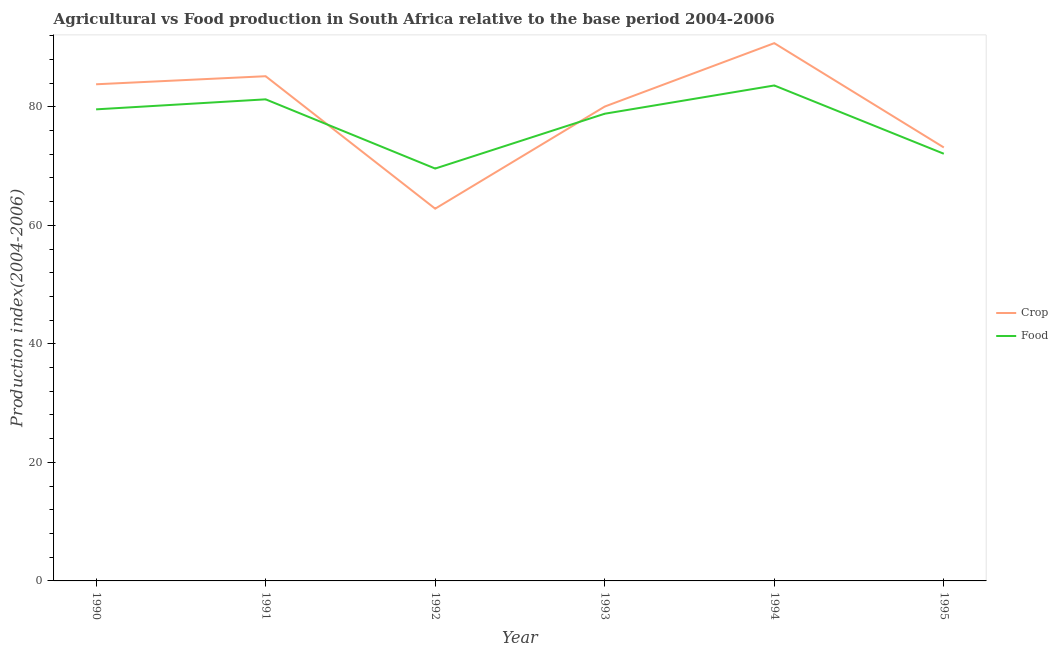What is the food production index in 1992?
Give a very brief answer. 69.58. Across all years, what is the maximum crop production index?
Your response must be concise. 90.74. Across all years, what is the minimum crop production index?
Offer a terse response. 62.81. What is the total food production index in the graph?
Your answer should be compact. 464.92. What is the difference between the food production index in 1993 and that in 1995?
Provide a short and direct response. 6.75. What is the difference between the food production index in 1995 and the crop production index in 1992?
Your answer should be very brief. 9.27. What is the average food production index per year?
Give a very brief answer. 77.49. In the year 1994, what is the difference between the crop production index and food production index?
Your answer should be compact. 7.14. What is the ratio of the food production index in 1990 to that in 1995?
Your response must be concise. 1.1. What is the difference between the highest and the second highest food production index?
Keep it short and to the point. 2.34. What is the difference between the highest and the lowest crop production index?
Your answer should be very brief. 27.93. Does the crop production index monotonically increase over the years?
Your answer should be compact. No. Are the values on the major ticks of Y-axis written in scientific E-notation?
Your answer should be compact. No. Does the graph contain grids?
Your answer should be very brief. No. How many legend labels are there?
Give a very brief answer. 2. What is the title of the graph?
Offer a very short reply. Agricultural vs Food production in South Africa relative to the base period 2004-2006. What is the label or title of the Y-axis?
Ensure brevity in your answer.  Production index(2004-2006). What is the Production index(2004-2006) of Crop in 1990?
Your response must be concise. 83.8. What is the Production index(2004-2006) of Food in 1990?
Your answer should be compact. 79.57. What is the Production index(2004-2006) in Crop in 1991?
Offer a terse response. 85.16. What is the Production index(2004-2006) of Food in 1991?
Offer a terse response. 81.26. What is the Production index(2004-2006) in Crop in 1992?
Your answer should be very brief. 62.81. What is the Production index(2004-2006) of Food in 1992?
Make the answer very short. 69.58. What is the Production index(2004-2006) of Crop in 1993?
Provide a succinct answer. 80.04. What is the Production index(2004-2006) of Food in 1993?
Give a very brief answer. 78.83. What is the Production index(2004-2006) in Crop in 1994?
Make the answer very short. 90.74. What is the Production index(2004-2006) in Food in 1994?
Your answer should be compact. 83.6. What is the Production index(2004-2006) of Crop in 1995?
Your response must be concise. 73.14. What is the Production index(2004-2006) of Food in 1995?
Your answer should be compact. 72.08. Across all years, what is the maximum Production index(2004-2006) in Crop?
Your response must be concise. 90.74. Across all years, what is the maximum Production index(2004-2006) in Food?
Provide a short and direct response. 83.6. Across all years, what is the minimum Production index(2004-2006) in Crop?
Offer a very short reply. 62.81. Across all years, what is the minimum Production index(2004-2006) of Food?
Your answer should be very brief. 69.58. What is the total Production index(2004-2006) in Crop in the graph?
Offer a very short reply. 475.69. What is the total Production index(2004-2006) of Food in the graph?
Your answer should be very brief. 464.92. What is the difference between the Production index(2004-2006) in Crop in 1990 and that in 1991?
Your response must be concise. -1.36. What is the difference between the Production index(2004-2006) in Food in 1990 and that in 1991?
Your answer should be very brief. -1.69. What is the difference between the Production index(2004-2006) of Crop in 1990 and that in 1992?
Offer a terse response. 20.99. What is the difference between the Production index(2004-2006) of Food in 1990 and that in 1992?
Your answer should be compact. 9.99. What is the difference between the Production index(2004-2006) in Crop in 1990 and that in 1993?
Provide a succinct answer. 3.76. What is the difference between the Production index(2004-2006) in Food in 1990 and that in 1993?
Ensure brevity in your answer.  0.74. What is the difference between the Production index(2004-2006) in Crop in 1990 and that in 1994?
Offer a very short reply. -6.94. What is the difference between the Production index(2004-2006) in Food in 1990 and that in 1994?
Offer a very short reply. -4.03. What is the difference between the Production index(2004-2006) in Crop in 1990 and that in 1995?
Your answer should be very brief. 10.66. What is the difference between the Production index(2004-2006) of Food in 1990 and that in 1995?
Give a very brief answer. 7.49. What is the difference between the Production index(2004-2006) in Crop in 1991 and that in 1992?
Provide a short and direct response. 22.35. What is the difference between the Production index(2004-2006) of Food in 1991 and that in 1992?
Keep it short and to the point. 11.68. What is the difference between the Production index(2004-2006) of Crop in 1991 and that in 1993?
Your answer should be very brief. 5.12. What is the difference between the Production index(2004-2006) of Food in 1991 and that in 1993?
Your response must be concise. 2.43. What is the difference between the Production index(2004-2006) in Crop in 1991 and that in 1994?
Provide a succinct answer. -5.58. What is the difference between the Production index(2004-2006) of Food in 1991 and that in 1994?
Keep it short and to the point. -2.34. What is the difference between the Production index(2004-2006) of Crop in 1991 and that in 1995?
Keep it short and to the point. 12.02. What is the difference between the Production index(2004-2006) in Food in 1991 and that in 1995?
Your answer should be compact. 9.18. What is the difference between the Production index(2004-2006) in Crop in 1992 and that in 1993?
Offer a very short reply. -17.23. What is the difference between the Production index(2004-2006) of Food in 1992 and that in 1993?
Ensure brevity in your answer.  -9.25. What is the difference between the Production index(2004-2006) of Crop in 1992 and that in 1994?
Make the answer very short. -27.93. What is the difference between the Production index(2004-2006) of Food in 1992 and that in 1994?
Offer a terse response. -14.02. What is the difference between the Production index(2004-2006) of Crop in 1992 and that in 1995?
Make the answer very short. -10.33. What is the difference between the Production index(2004-2006) in Food in 1993 and that in 1994?
Keep it short and to the point. -4.77. What is the difference between the Production index(2004-2006) of Food in 1993 and that in 1995?
Ensure brevity in your answer.  6.75. What is the difference between the Production index(2004-2006) in Food in 1994 and that in 1995?
Make the answer very short. 11.52. What is the difference between the Production index(2004-2006) of Crop in 1990 and the Production index(2004-2006) of Food in 1991?
Your response must be concise. 2.54. What is the difference between the Production index(2004-2006) of Crop in 1990 and the Production index(2004-2006) of Food in 1992?
Ensure brevity in your answer.  14.22. What is the difference between the Production index(2004-2006) of Crop in 1990 and the Production index(2004-2006) of Food in 1993?
Your response must be concise. 4.97. What is the difference between the Production index(2004-2006) in Crop in 1990 and the Production index(2004-2006) in Food in 1994?
Your answer should be very brief. 0.2. What is the difference between the Production index(2004-2006) in Crop in 1990 and the Production index(2004-2006) in Food in 1995?
Offer a very short reply. 11.72. What is the difference between the Production index(2004-2006) in Crop in 1991 and the Production index(2004-2006) in Food in 1992?
Offer a terse response. 15.58. What is the difference between the Production index(2004-2006) in Crop in 1991 and the Production index(2004-2006) in Food in 1993?
Your response must be concise. 6.33. What is the difference between the Production index(2004-2006) in Crop in 1991 and the Production index(2004-2006) in Food in 1994?
Make the answer very short. 1.56. What is the difference between the Production index(2004-2006) of Crop in 1991 and the Production index(2004-2006) of Food in 1995?
Make the answer very short. 13.08. What is the difference between the Production index(2004-2006) of Crop in 1992 and the Production index(2004-2006) of Food in 1993?
Keep it short and to the point. -16.02. What is the difference between the Production index(2004-2006) in Crop in 1992 and the Production index(2004-2006) in Food in 1994?
Give a very brief answer. -20.79. What is the difference between the Production index(2004-2006) of Crop in 1992 and the Production index(2004-2006) of Food in 1995?
Make the answer very short. -9.27. What is the difference between the Production index(2004-2006) in Crop in 1993 and the Production index(2004-2006) in Food in 1994?
Keep it short and to the point. -3.56. What is the difference between the Production index(2004-2006) in Crop in 1993 and the Production index(2004-2006) in Food in 1995?
Offer a terse response. 7.96. What is the difference between the Production index(2004-2006) in Crop in 1994 and the Production index(2004-2006) in Food in 1995?
Provide a short and direct response. 18.66. What is the average Production index(2004-2006) in Crop per year?
Provide a succinct answer. 79.28. What is the average Production index(2004-2006) in Food per year?
Provide a short and direct response. 77.49. In the year 1990, what is the difference between the Production index(2004-2006) in Crop and Production index(2004-2006) in Food?
Your response must be concise. 4.23. In the year 1991, what is the difference between the Production index(2004-2006) in Crop and Production index(2004-2006) in Food?
Your answer should be very brief. 3.9. In the year 1992, what is the difference between the Production index(2004-2006) in Crop and Production index(2004-2006) in Food?
Your answer should be very brief. -6.77. In the year 1993, what is the difference between the Production index(2004-2006) of Crop and Production index(2004-2006) of Food?
Offer a very short reply. 1.21. In the year 1994, what is the difference between the Production index(2004-2006) of Crop and Production index(2004-2006) of Food?
Ensure brevity in your answer.  7.14. In the year 1995, what is the difference between the Production index(2004-2006) of Crop and Production index(2004-2006) of Food?
Make the answer very short. 1.06. What is the ratio of the Production index(2004-2006) of Crop in 1990 to that in 1991?
Your answer should be compact. 0.98. What is the ratio of the Production index(2004-2006) in Food in 1990 to that in 1991?
Keep it short and to the point. 0.98. What is the ratio of the Production index(2004-2006) in Crop in 1990 to that in 1992?
Your response must be concise. 1.33. What is the ratio of the Production index(2004-2006) of Food in 1990 to that in 1992?
Provide a succinct answer. 1.14. What is the ratio of the Production index(2004-2006) in Crop in 1990 to that in 1993?
Make the answer very short. 1.05. What is the ratio of the Production index(2004-2006) in Food in 1990 to that in 1993?
Your response must be concise. 1.01. What is the ratio of the Production index(2004-2006) of Crop in 1990 to that in 1994?
Make the answer very short. 0.92. What is the ratio of the Production index(2004-2006) in Food in 1990 to that in 1994?
Your answer should be very brief. 0.95. What is the ratio of the Production index(2004-2006) of Crop in 1990 to that in 1995?
Give a very brief answer. 1.15. What is the ratio of the Production index(2004-2006) of Food in 1990 to that in 1995?
Your answer should be very brief. 1.1. What is the ratio of the Production index(2004-2006) in Crop in 1991 to that in 1992?
Ensure brevity in your answer.  1.36. What is the ratio of the Production index(2004-2006) in Food in 1991 to that in 1992?
Ensure brevity in your answer.  1.17. What is the ratio of the Production index(2004-2006) of Crop in 1991 to that in 1993?
Keep it short and to the point. 1.06. What is the ratio of the Production index(2004-2006) of Food in 1991 to that in 1993?
Give a very brief answer. 1.03. What is the ratio of the Production index(2004-2006) in Crop in 1991 to that in 1994?
Your answer should be compact. 0.94. What is the ratio of the Production index(2004-2006) of Crop in 1991 to that in 1995?
Keep it short and to the point. 1.16. What is the ratio of the Production index(2004-2006) of Food in 1991 to that in 1995?
Ensure brevity in your answer.  1.13. What is the ratio of the Production index(2004-2006) of Crop in 1992 to that in 1993?
Give a very brief answer. 0.78. What is the ratio of the Production index(2004-2006) in Food in 1992 to that in 1993?
Your answer should be compact. 0.88. What is the ratio of the Production index(2004-2006) of Crop in 1992 to that in 1994?
Keep it short and to the point. 0.69. What is the ratio of the Production index(2004-2006) in Food in 1992 to that in 1994?
Give a very brief answer. 0.83. What is the ratio of the Production index(2004-2006) of Crop in 1992 to that in 1995?
Provide a succinct answer. 0.86. What is the ratio of the Production index(2004-2006) in Food in 1992 to that in 1995?
Make the answer very short. 0.97. What is the ratio of the Production index(2004-2006) in Crop in 1993 to that in 1994?
Your answer should be very brief. 0.88. What is the ratio of the Production index(2004-2006) in Food in 1993 to that in 1994?
Make the answer very short. 0.94. What is the ratio of the Production index(2004-2006) in Crop in 1993 to that in 1995?
Offer a terse response. 1.09. What is the ratio of the Production index(2004-2006) of Food in 1993 to that in 1995?
Keep it short and to the point. 1.09. What is the ratio of the Production index(2004-2006) in Crop in 1994 to that in 1995?
Make the answer very short. 1.24. What is the ratio of the Production index(2004-2006) in Food in 1994 to that in 1995?
Offer a very short reply. 1.16. What is the difference between the highest and the second highest Production index(2004-2006) of Crop?
Give a very brief answer. 5.58. What is the difference between the highest and the second highest Production index(2004-2006) in Food?
Your response must be concise. 2.34. What is the difference between the highest and the lowest Production index(2004-2006) in Crop?
Your response must be concise. 27.93. What is the difference between the highest and the lowest Production index(2004-2006) in Food?
Your answer should be compact. 14.02. 